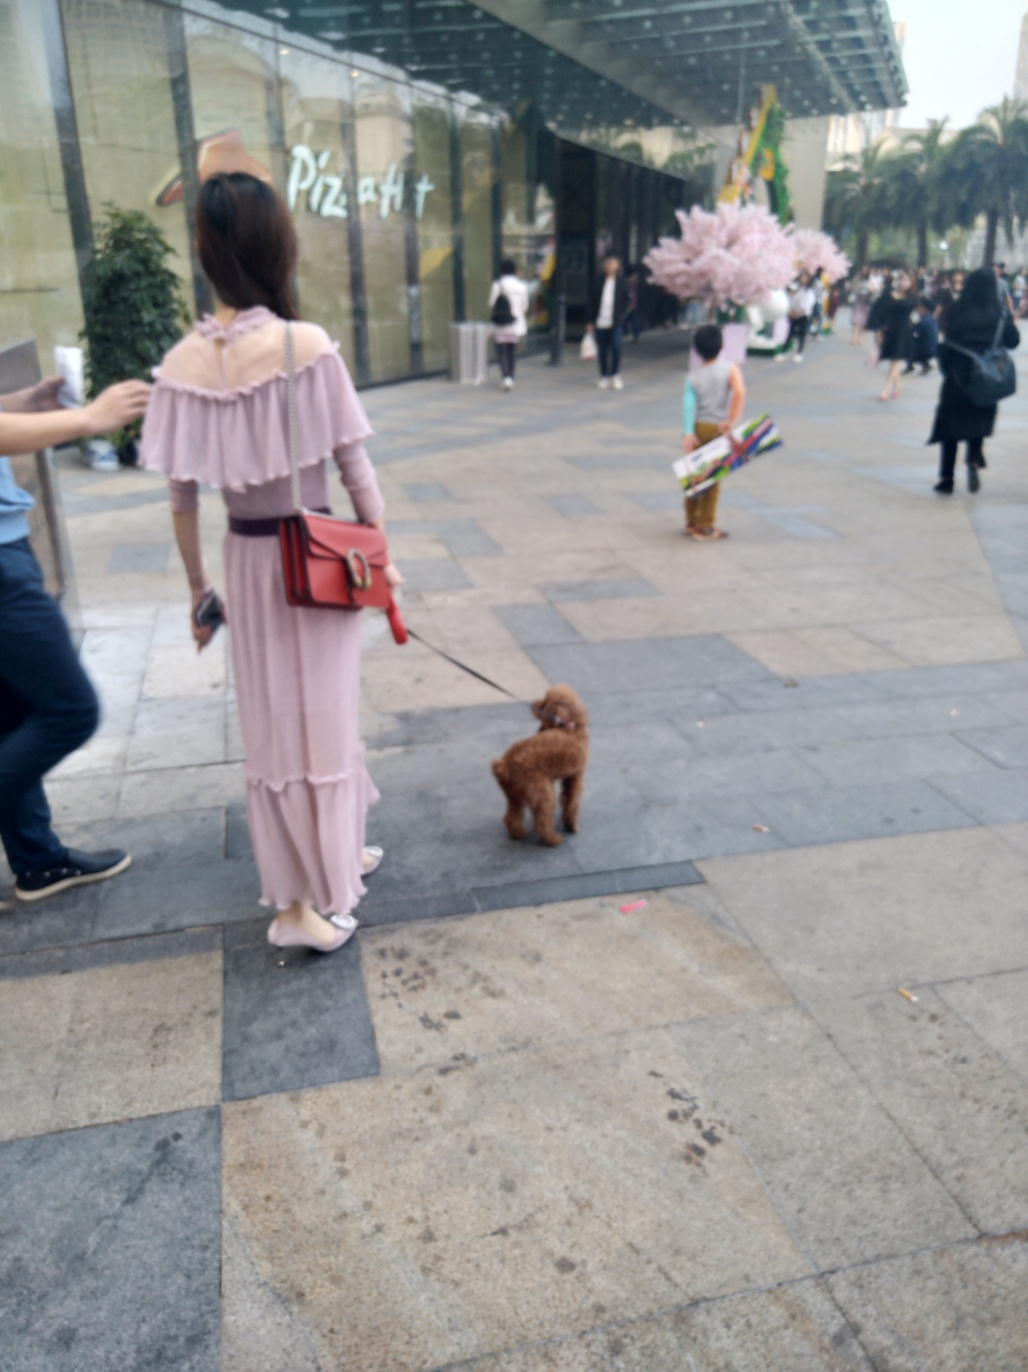What is the central subject of this photo, and what atmosphere does it convey? The central subject of this photo seems to be the everyday street scene, capturing a moment in the lives of the people within a city environment. The atmosphere conveyed is one of relaxed urban daily life, with individuals engaged in various activities such as walking, shopping, or spending time with pets, all set against a backdrop that blends architectural details with the vitality of city dwellers. 